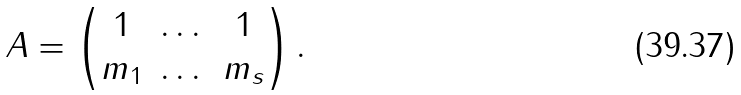<formula> <loc_0><loc_0><loc_500><loc_500>A = \left ( \begin{matrix} 1 & \dots & 1 \\ m _ { 1 } & \dots & m _ { s } \end{matrix} \right ) .</formula> 